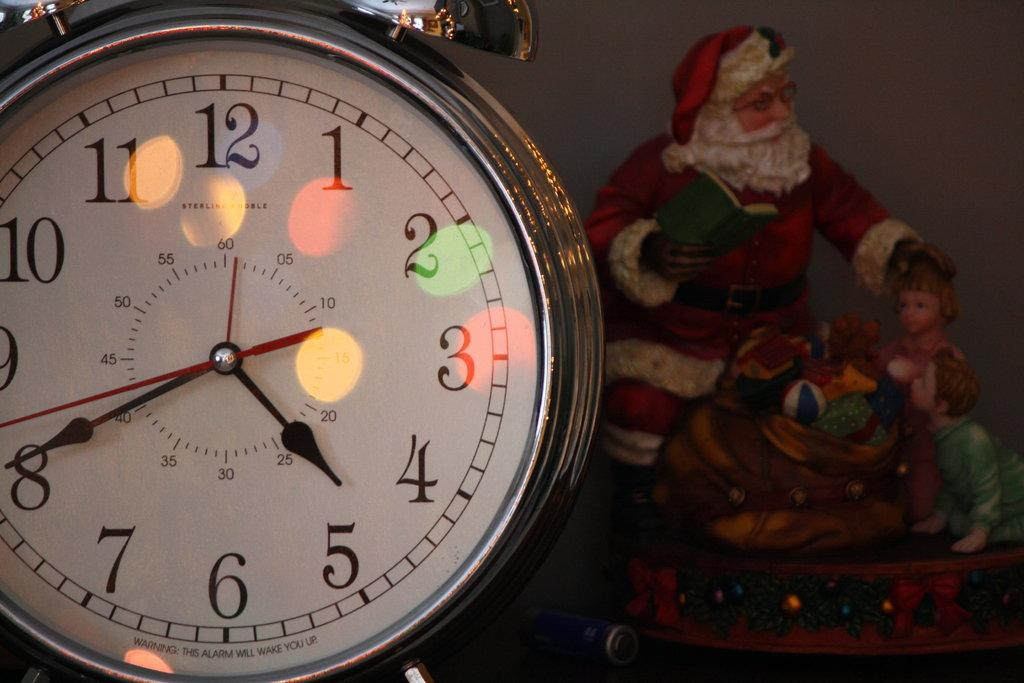<image>
Relay a brief, clear account of the picture shown. The alarm clock next to the Santa figurine reads 4:41. 